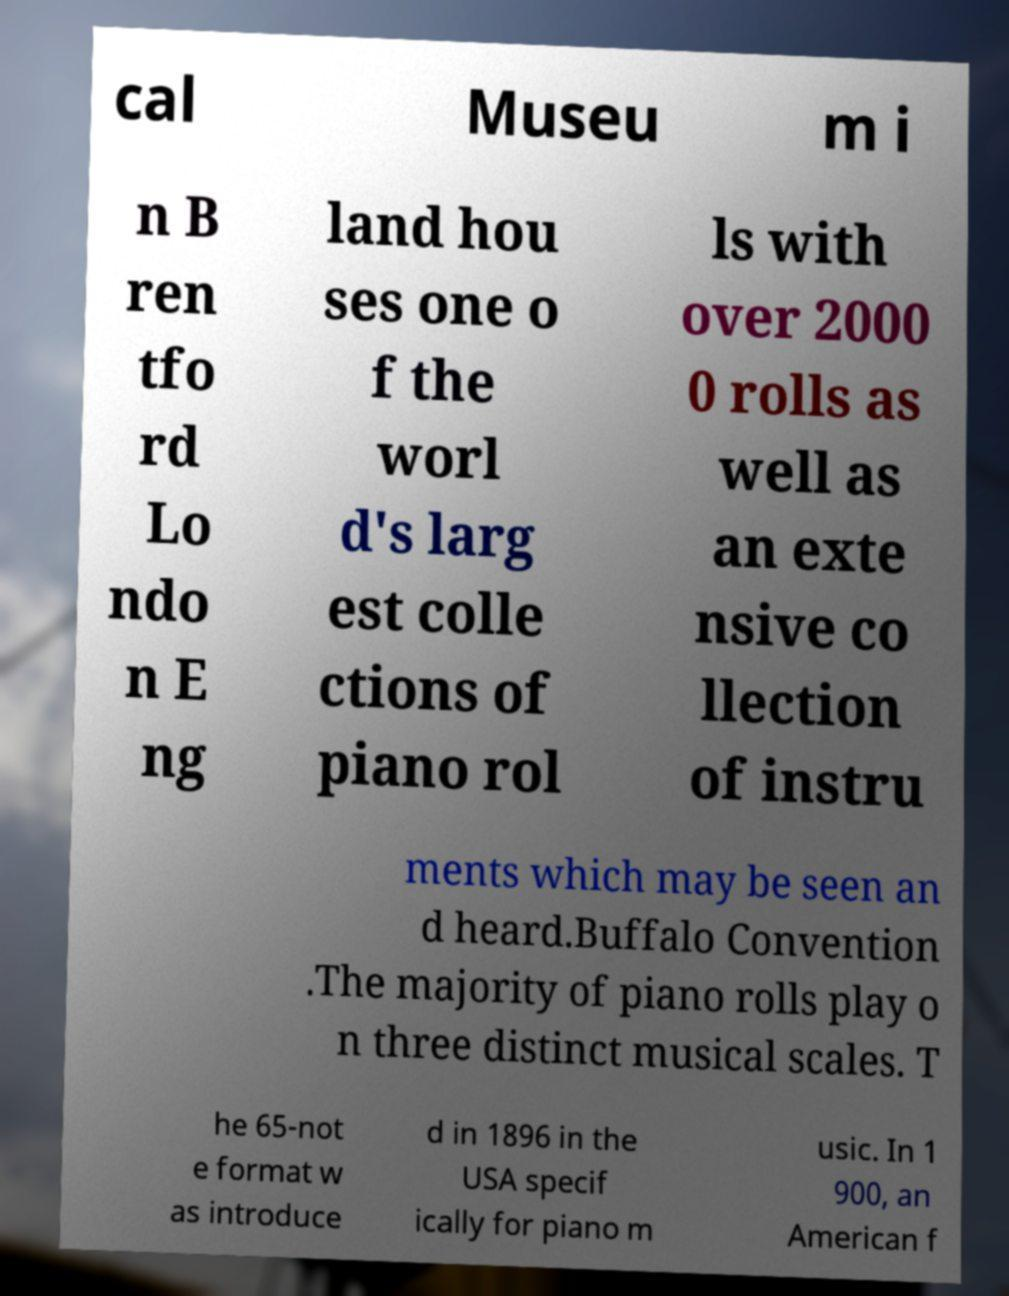Can you read and provide the text displayed in the image?This photo seems to have some interesting text. Can you extract and type it out for me? cal Museu m i n B ren tfo rd Lo ndo n E ng land hou ses one o f the worl d's larg est colle ctions of piano rol ls with over 2000 0 rolls as well as an exte nsive co llection of instru ments which may be seen an d heard.Buffalo Convention .The majority of piano rolls play o n three distinct musical scales. T he 65-not e format w as introduce d in 1896 in the USA specif ically for piano m usic. In 1 900, an American f 